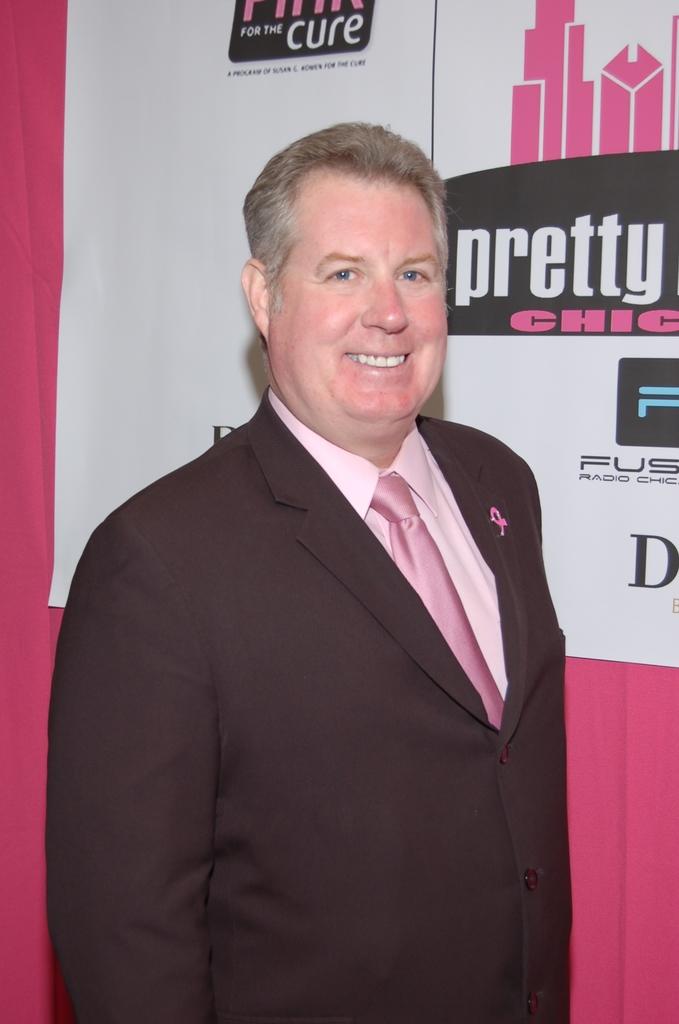What is next to his face?
Ensure brevity in your answer.  Pretty. Race for the what?
Make the answer very short. Cure. 